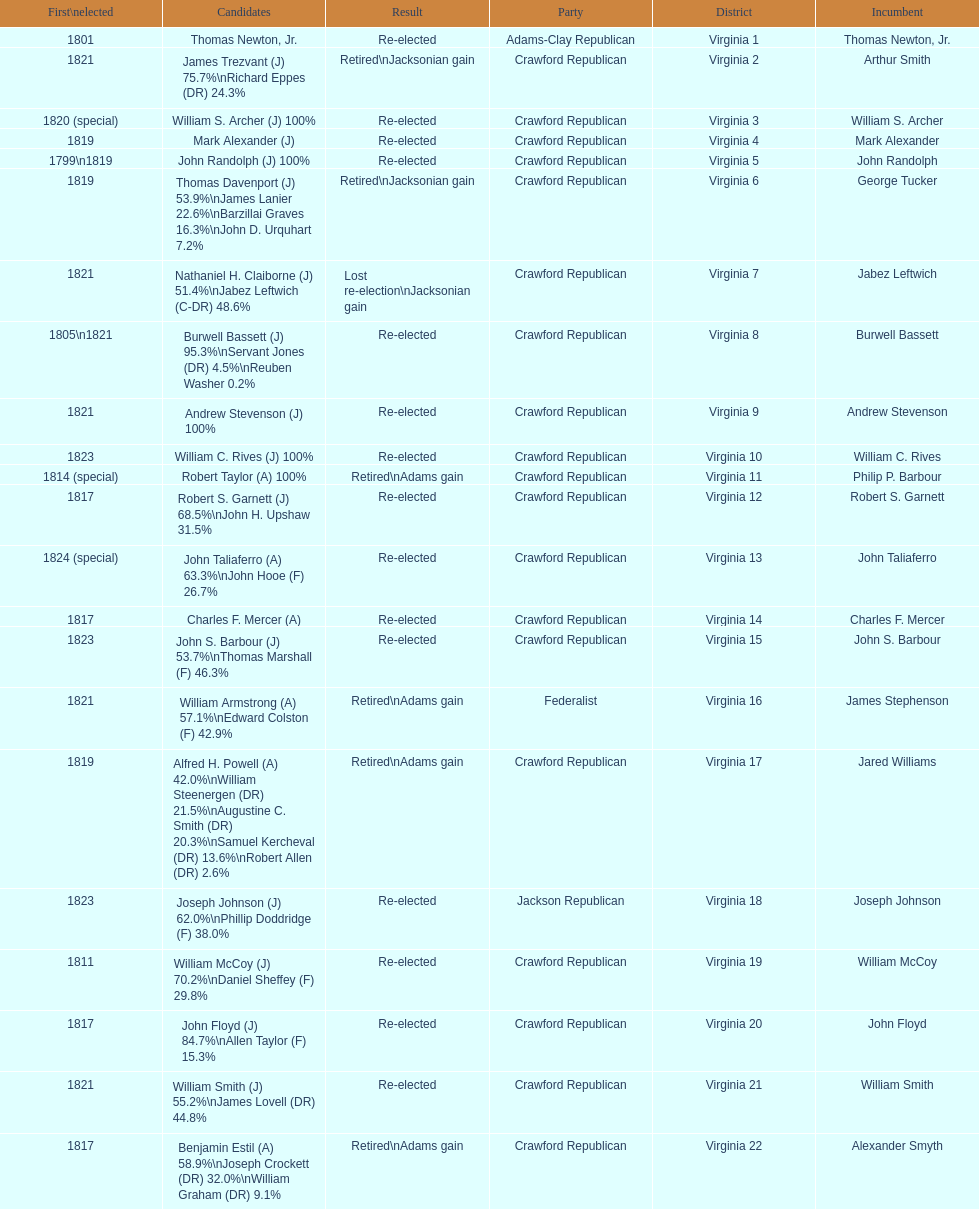Number of incumbents who retired or lost re-election 7. 